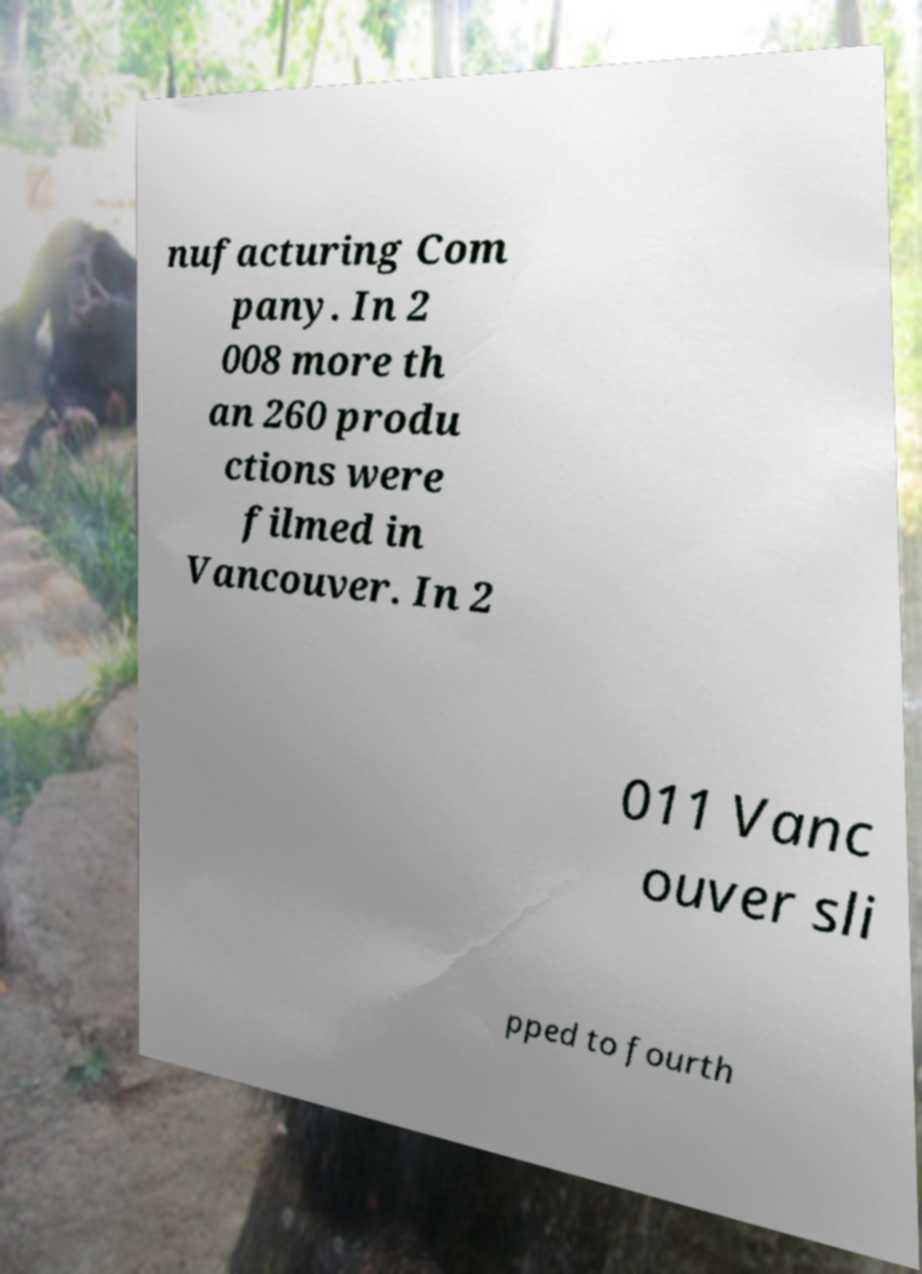There's text embedded in this image that I need extracted. Can you transcribe it verbatim? nufacturing Com pany. In 2 008 more th an 260 produ ctions were filmed in Vancouver. In 2 011 Vanc ouver sli pped to fourth 